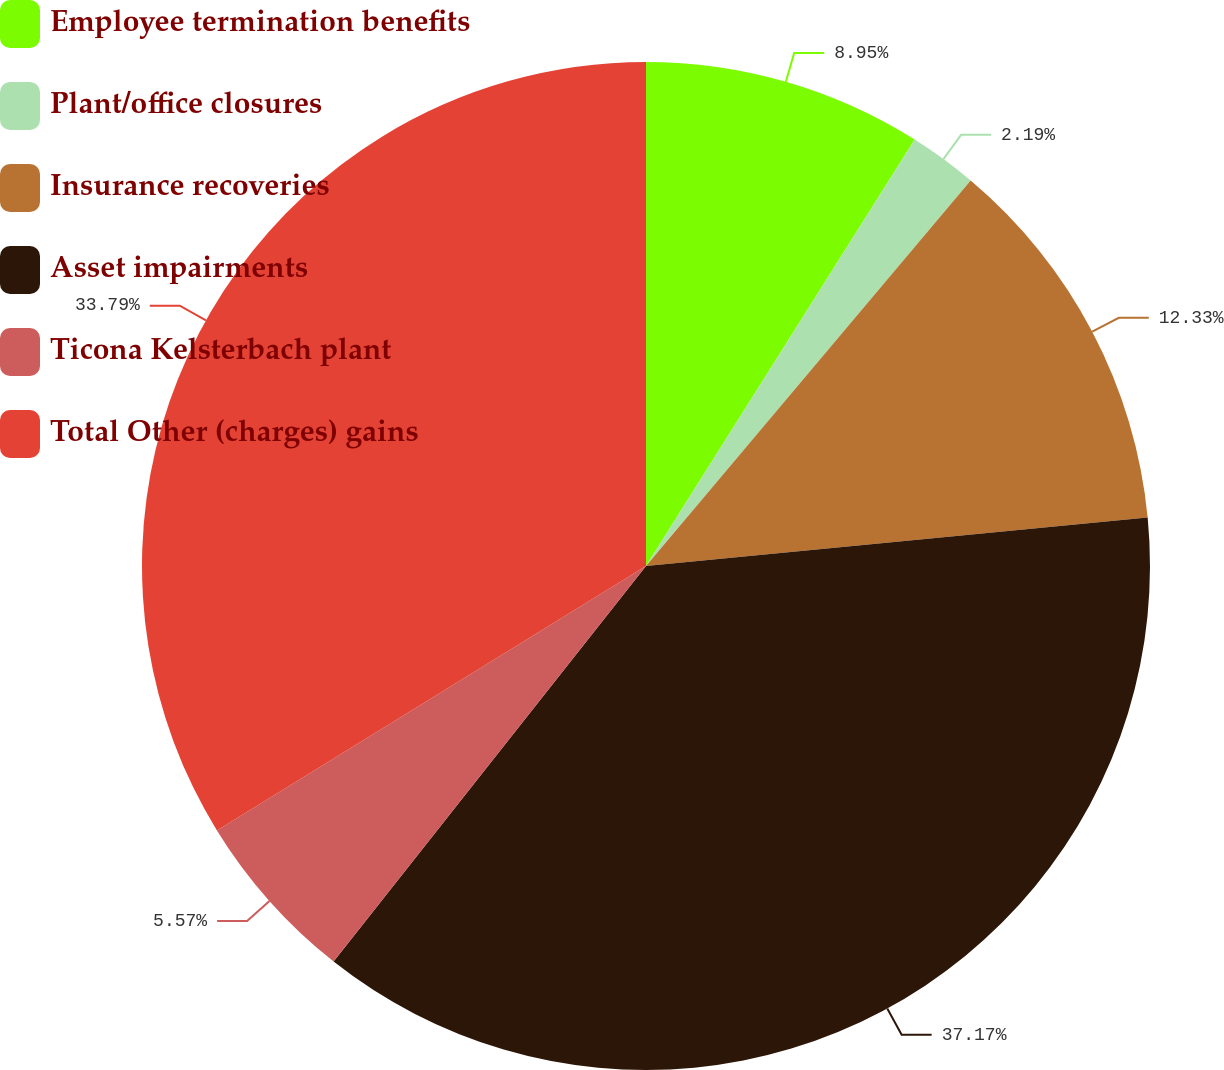Convert chart to OTSL. <chart><loc_0><loc_0><loc_500><loc_500><pie_chart><fcel>Employee termination benefits<fcel>Plant/office closures<fcel>Insurance recoveries<fcel>Asset impairments<fcel>Ticona Kelsterbach plant<fcel>Total Other (charges) gains<nl><fcel>8.95%<fcel>2.19%<fcel>12.33%<fcel>37.17%<fcel>5.57%<fcel>33.79%<nl></chart> 